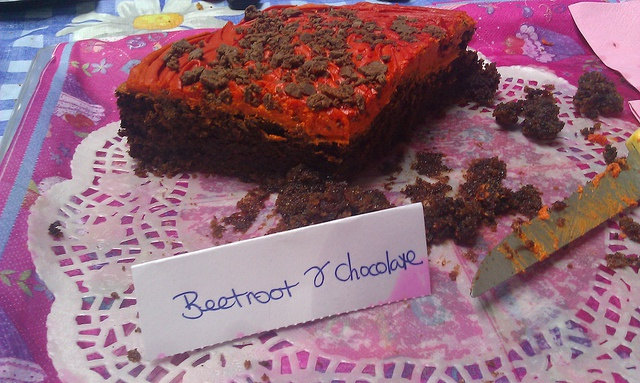Describe the objects in this image and their specific colors. I can see cake in darkgray, black, maroon, and brown tones and knife in darkgray, gray, and brown tones in this image. 